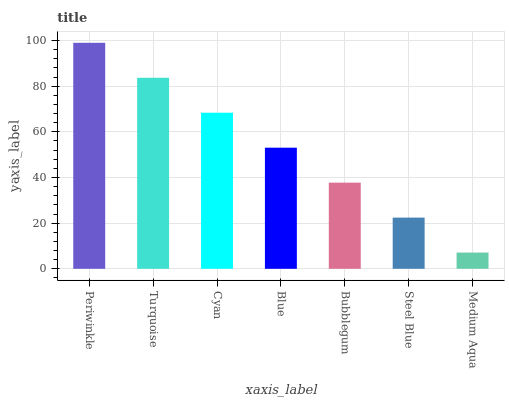Is Medium Aqua the minimum?
Answer yes or no. Yes. Is Periwinkle the maximum?
Answer yes or no. Yes. Is Turquoise the minimum?
Answer yes or no. No. Is Turquoise the maximum?
Answer yes or no. No. Is Periwinkle greater than Turquoise?
Answer yes or no. Yes. Is Turquoise less than Periwinkle?
Answer yes or no. Yes. Is Turquoise greater than Periwinkle?
Answer yes or no. No. Is Periwinkle less than Turquoise?
Answer yes or no. No. Is Blue the high median?
Answer yes or no. Yes. Is Blue the low median?
Answer yes or no. Yes. Is Turquoise the high median?
Answer yes or no. No. Is Steel Blue the low median?
Answer yes or no. No. 